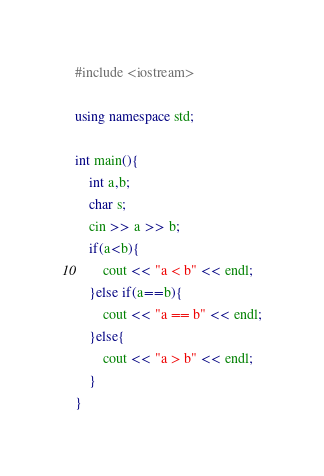<code> <loc_0><loc_0><loc_500><loc_500><_C++_>#include <iostream>

using namespace std;

int main(){
    int a,b;
    char s;
    cin >> a >> b;
    if(a<b){
        cout << "a < b" << endl;
    }else if(a==b){
        cout << "a == b" << endl;
    }else{
        cout << "a > b" << endl;
    }
}
</code> 